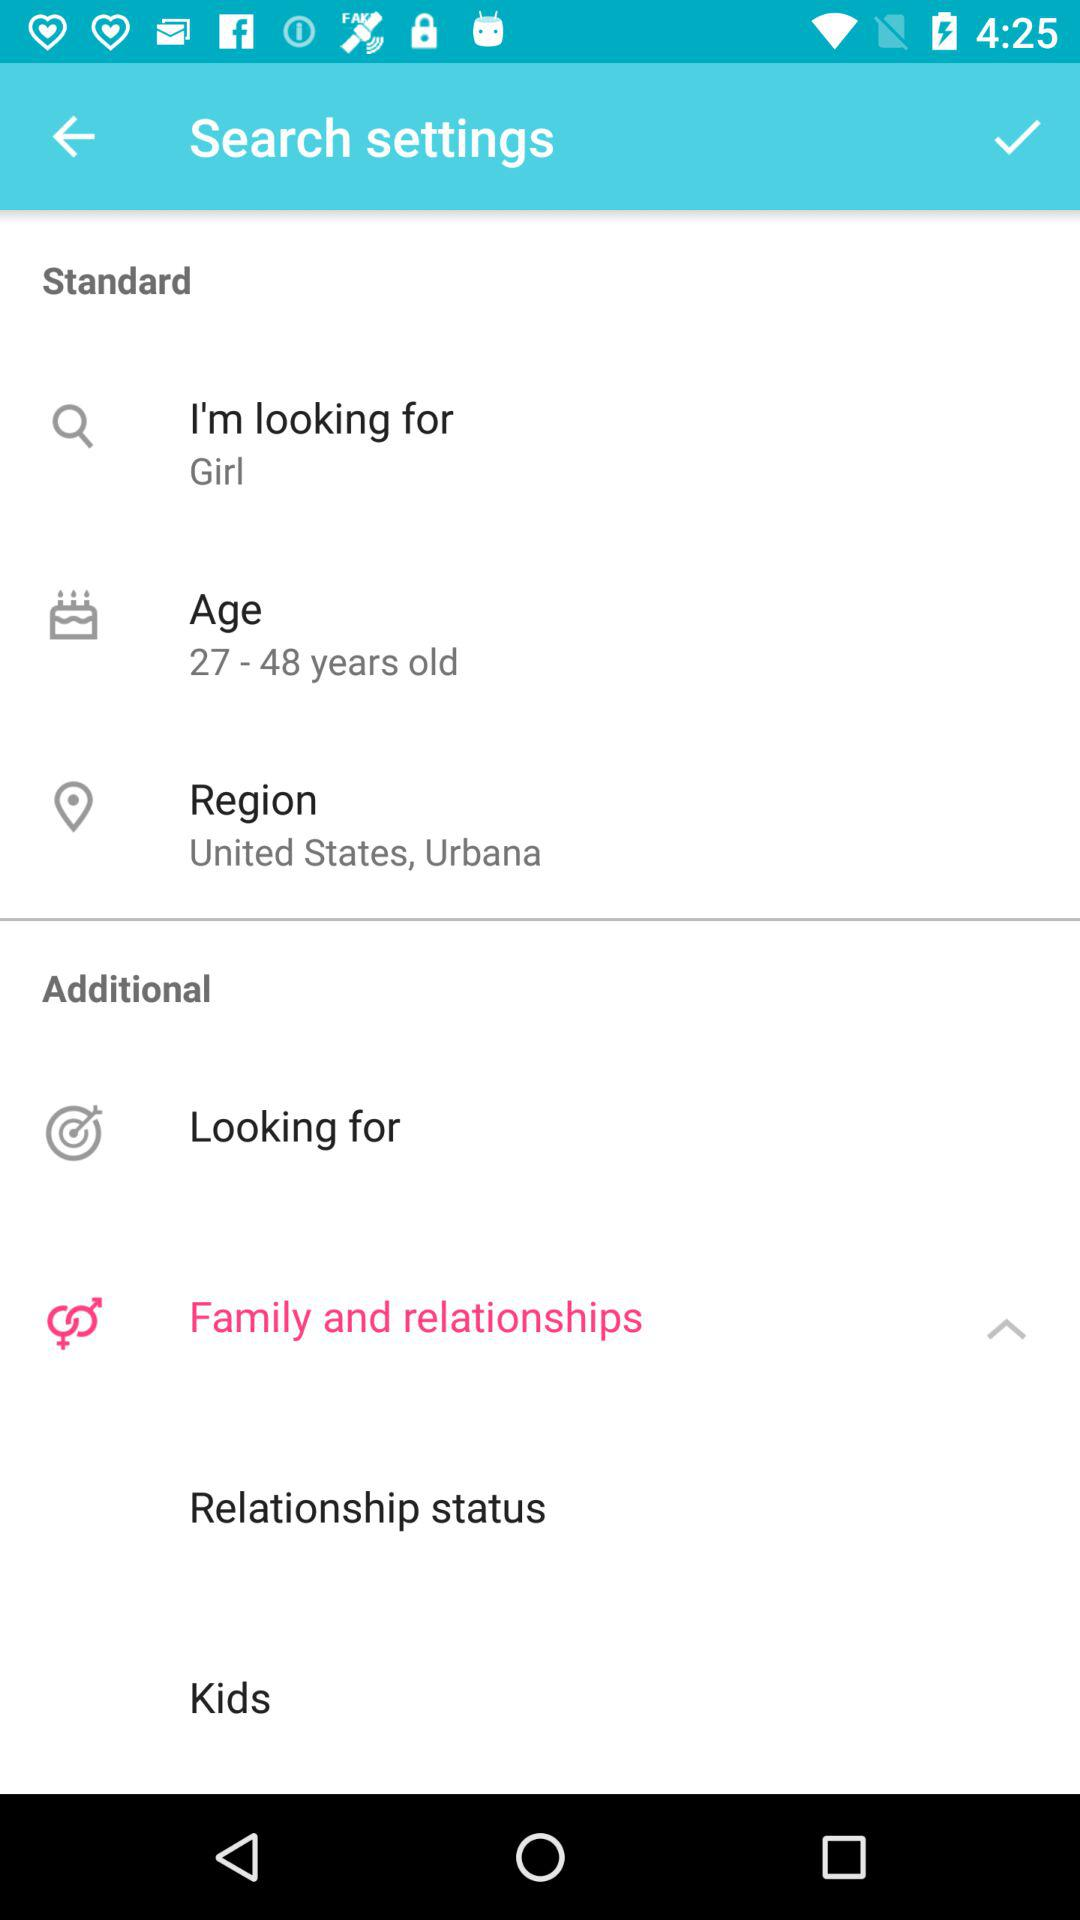How many items are in the Family and relationships section?
Answer the question using a single word or phrase. 2 